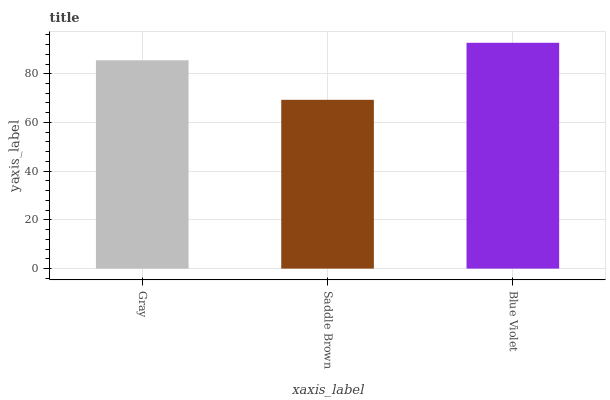Is Saddle Brown the minimum?
Answer yes or no. Yes. Is Blue Violet the maximum?
Answer yes or no. Yes. Is Blue Violet the minimum?
Answer yes or no. No. Is Saddle Brown the maximum?
Answer yes or no. No. Is Blue Violet greater than Saddle Brown?
Answer yes or no. Yes. Is Saddle Brown less than Blue Violet?
Answer yes or no. Yes. Is Saddle Brown greater than Blue Violet?
Answer yes or no. No. Is Blue Violet less than Saddle Brown?
Answer yes or no. No. Is Gray the high median?
Answer yes or no. Yes. Is Gray the low median?
Answer yes or no. Yes. Is Blue Violet the high median?
Answer yes or no. No. Is Blue Violet the low median?
Answer yes or no. No. 